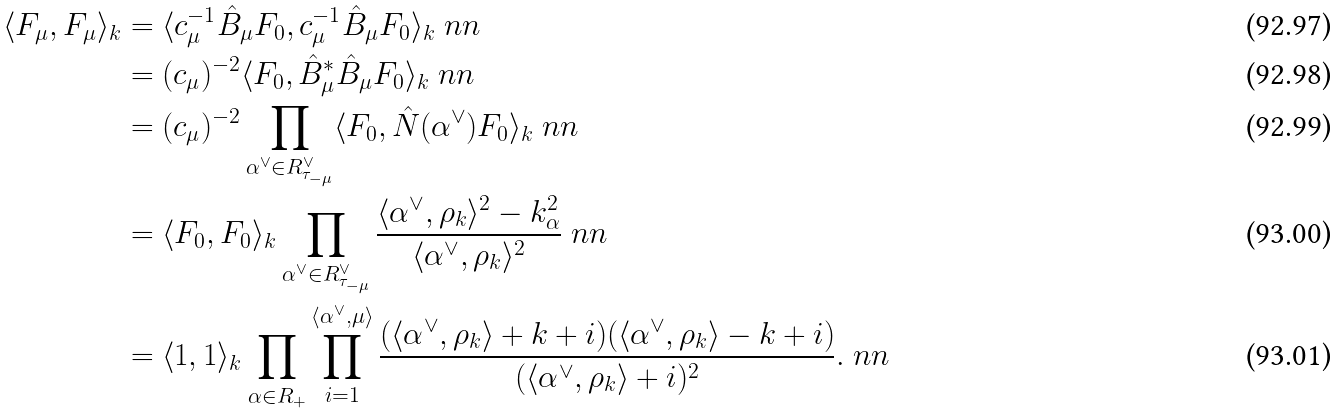Convert formula to latex. <formula><loc_0><loc_0><loc_500><loc_500>\langle F _ { \mu } , F _ { \mu } \rangle _ { k } & = \langle c _ { \mu } ^ { - 1 } \hat { B } _ { \mu } F _ { 0 } , c _ { \mu } ^ { - 1 } \hat { B } _ { \mu } F _ { 0 } \rangle _ { k } \ n n \\ & = ( c _ { \mu } ) ^ { - 2 } \langle F _ { 0 } , \hat { B } _ { \mu } ^ { * } \hat { B } _ { \mu } F _ { 0 } \rangle _ { k } \ n n \\ & = ( c _ { \mu } ) ^ { - 2 } \prod _ { \alpha ^ { \vee } \in R _ { \tau _ { - \mu } } ^ { \vee } } \langle F _ { 0 } , \hat { N } ( \alpha ^ { \vee } ) F _ { 0 } \rangle _ { k } \ n n \\ & = \langle F _ { 0 } , F _ { 0 } \rangle _ { k } \prod _ { \alpha ^ { \vee } \in R _ { \tau _ { - \mu } } ^ { \vee } } \frac { \langle \alpha ^ { \vee } , \rho _ { k } \rangle ^ { 2 } - k _ { \alpha } ^ { 2 } } { \langle \alpha ^ { \vee } , \rho _ { k } \rangle ^ { 2 } } \ n n \\ & = \langle 1 , 1 \rangle _ { k } \prod _ { \alpha \in R _ { + } } \prod _ { i = 1 } ^ { \langle \alpha ^ { \vee } , \mu \rangle } \frac { ( \langle \alpha ^ { \vee } , \rho _ { k } \rangle + k + i ) ( \langle \alpha ^ { \vee } , \rho _ { k } \rangle - k + i ) } { ( \langle \alpha ^ { \vee } , \rho _ { k } \rangle + i ) ^ { 2 } } . \ n n</formula> 